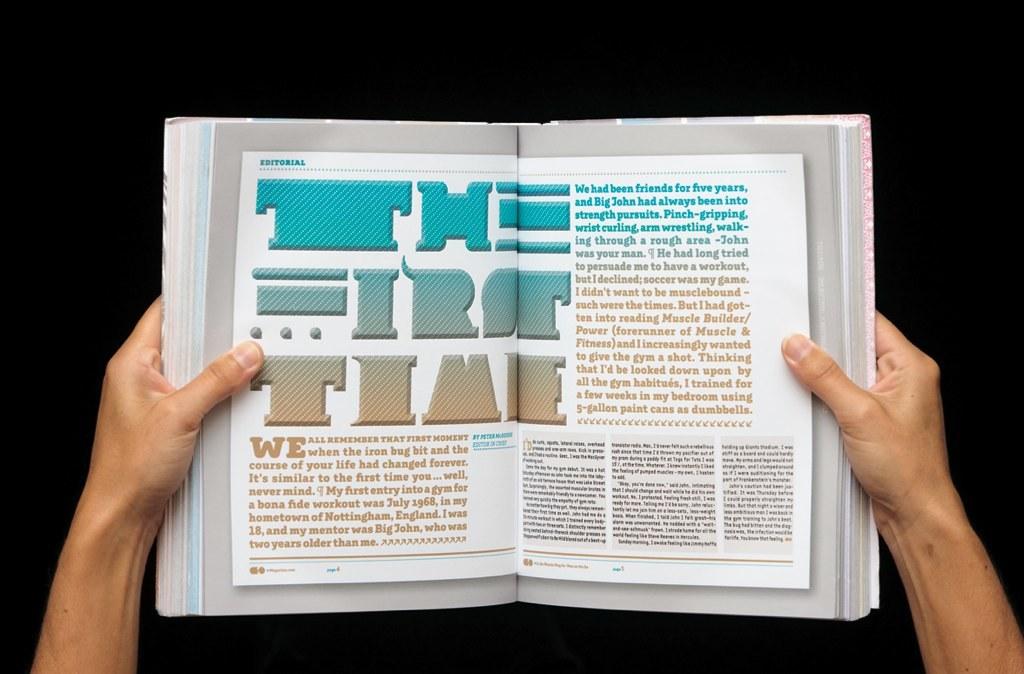What is the title of the article?
Your answer should be compact. The first time. What is the name of this chapter?
Offer a terse response. The first time. 